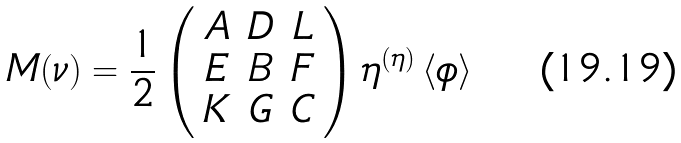<formula> <loc_0><loc_0><loc_500><loc_500>M ( \nu ) = \frac { 1 } { 2 } \left ( \begin{array} { c c c } A & D & L \\ E & B & F \\ K & G & C \end{array} \right ) \eta ^ { ( \eta ) } \left \langle \phi \right \rangle</formula> 